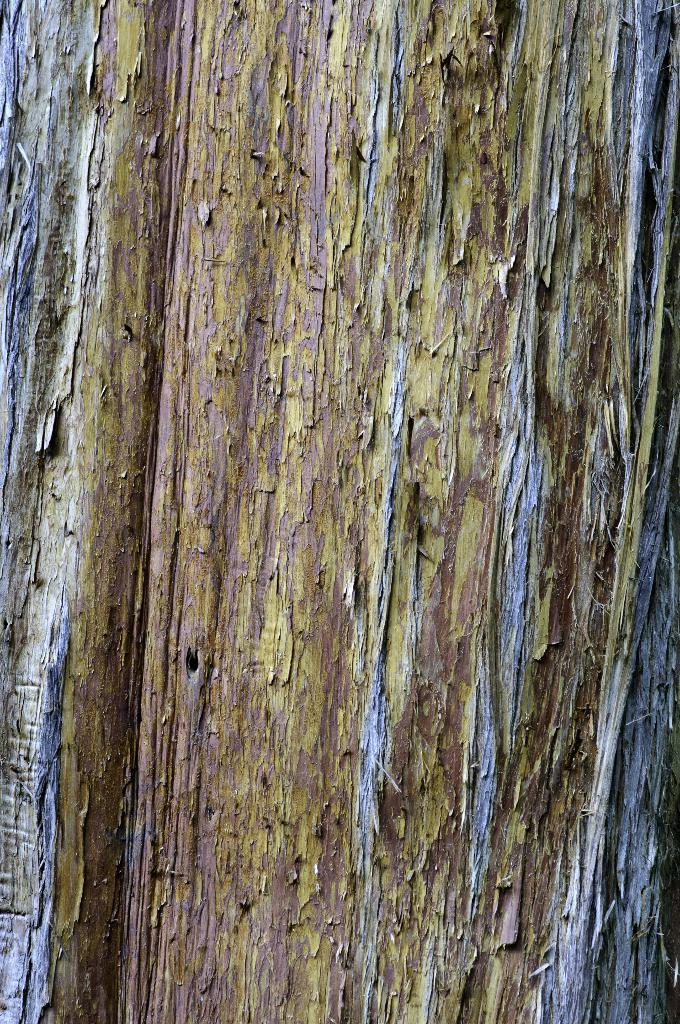What material is located in the center of the image? There is wood in the center of the image. What scientific discovery is depicted in the image? There is no scientific discovery depicted in the image; it only features wood in the center. What type of crate is shown holding the wood in the image? There is no crate present in the image; it only features wood in the center. 